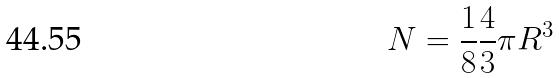<formula> <loc_0><loc_0><loc_500><loc_500>N = \frac { 1 } { 8 } \frac { 4 } { 3 } \pi R ^ { 3 }</formula> 